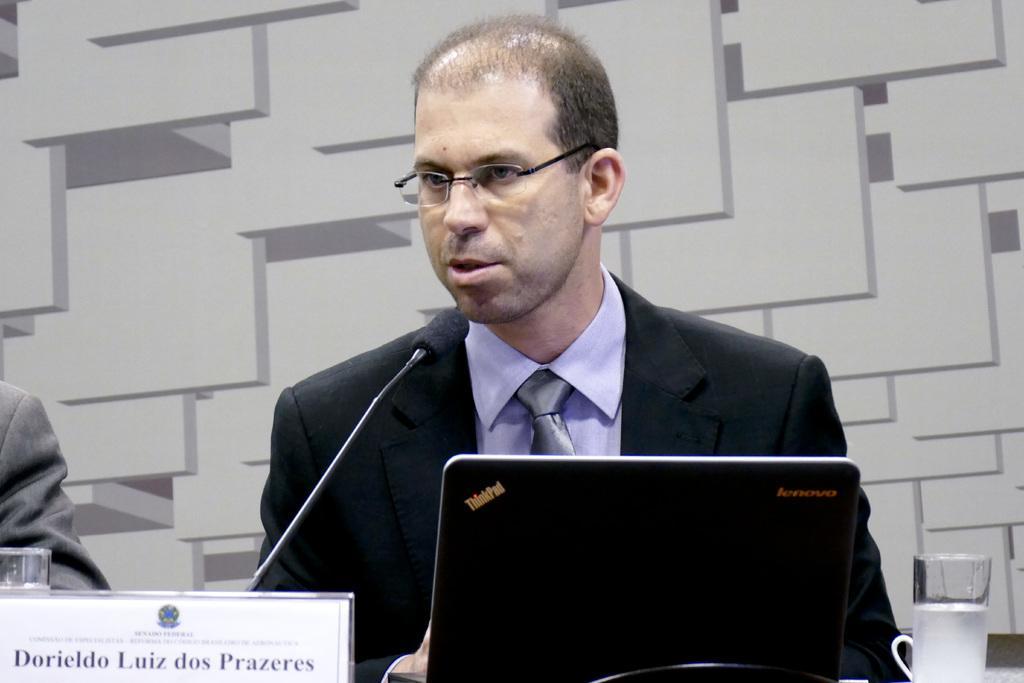How would you summarize this image in a sentence or two? In this image we can see few people. There is a laptop in the image. There is a mic in the in the image. There is a glass at the right side of the image. We can see some text on the board. 